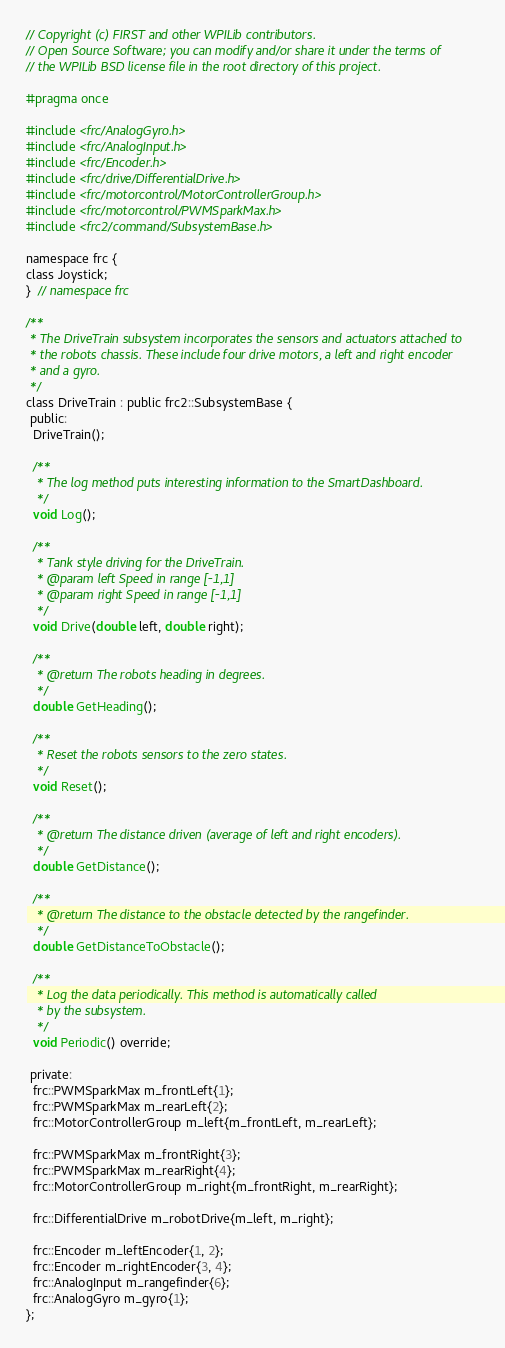Convert code to text. <code><loc_0><loc_0><loc_500><loc_500><_C_>// Copyright (c) FIRST and other WPILib contributors.
// Open Source Software; you can modify and/or share it under the terms of
// the WPILib BSD license file in the root directory of this project.

#pragma once

#include <frc/AnalogGyro.h>
#include <frc/AnalogInput.h>
#include <frc/Encoder.h>
#include <frc/drive/DifferentialDrive.h>
#include <frc/motorcontrol/MotorControllerGroup.h>
#include <frc/motorcontrol/PWMSparkMax.h>
#include <frc2/command/SubsystemBase.h>

namespace frc {
class Joystick;
}  // namespace frc

/**
 * The DriveTrain subsystem incorporates the sensors and actuators attached to
 * the robots chassis. These include four drive motors, a left and right encoder
 * and a gyro.
 */
class DriveTrain : public frc2::SubsystemBase {
 public:
  DriveTrain();

  /**
   * The log method puts interesting information to the SmartDashboard.
   */
  void Log();

  /**
   * Tank style driving for the DriveTrain.
   * @param left Speed in range [-1,1]
   * @param right Speed in range [-1,1]
   */
  void Drive(double left, double right);

  /**
   * @return The robots heading in degrees.
   */
  double GetHeading();

  /**
   * Reset the robots sensors to the zero states.
   */
  void Reset();

  /**
   * @return The distance driven (average of left and right encoders).
   */
  double GetDistance();

  /**
   * @return The distance to the obstacle detected by the rangefinder.
   */
  double GetDistanceToObstacle();

  /**
   * Log the data periodically. This method is automatically called
   * by the subsystem.
   */
  void Periodic() override;

 private:
  frc::PWMSparkMax m_frontLeft{1};
  frc::PWMSparkMax m_rearLeft{2};
  frc::MotorControllerGroup m_left{m_frontLeft, m_rearLeft};

  frc::PWMSparkMax m_frontRight{3};
  frc::PWMSparkMax m_rearRight{4};
  frc::MotorControllerGroup m_right{m_frontRight, m_rearRight};

  frc::DifferentialDrive m_robotDrive{m_left, m_right};

  frc::Encoder m_leftEncoder{1, 2};
  frc::Encoder m_rightEncoder{3, 4};
  frc::AnalogInput m_rangefinder{6};
  frc::AnalogGyro m_gyro{1};
};
</code> 